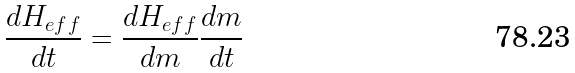Convert formula to latex. <formula><loc_0><loc_0><loc_500><loc_500>\frac { d H _ { e f f } } { d t } = \frac { d H _ { e f f } } { d m } \frac { d m } { d t }</formula> 